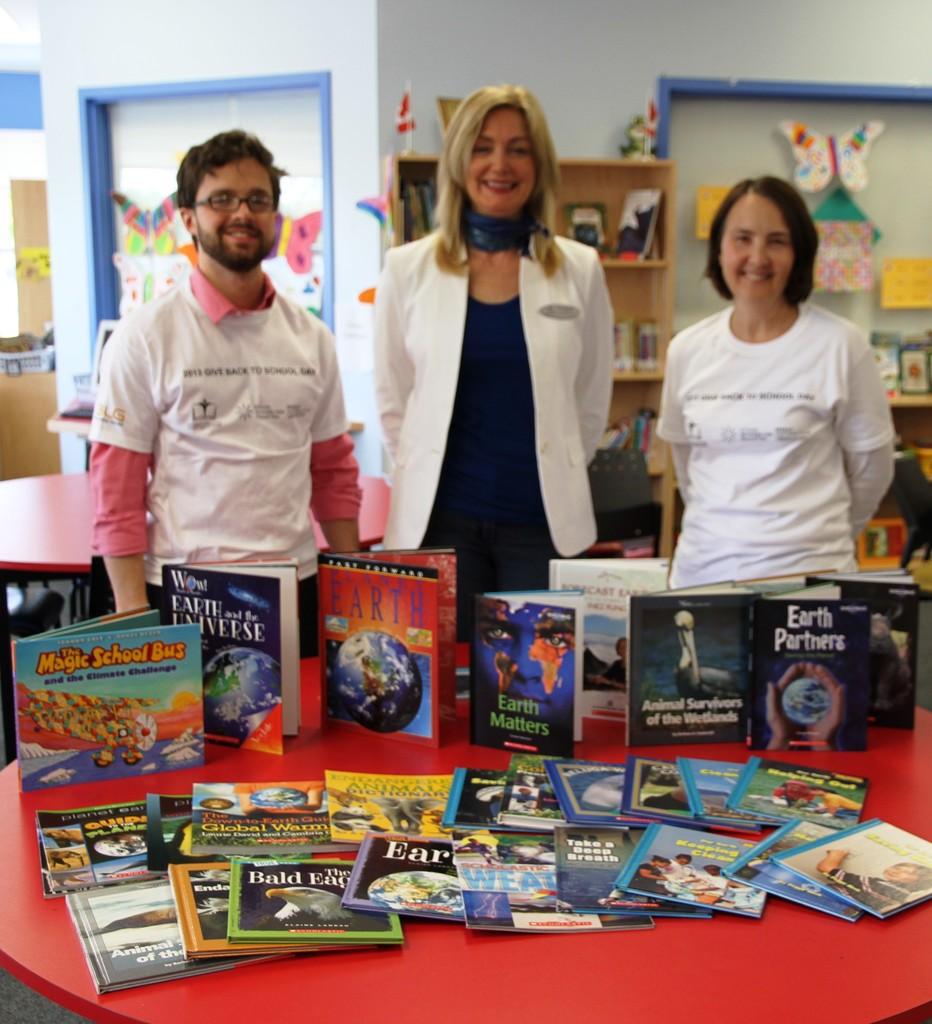What kind of school bus is mentioned in the title of the book on the left?
Keep it short and to the point. Magic school bus. 